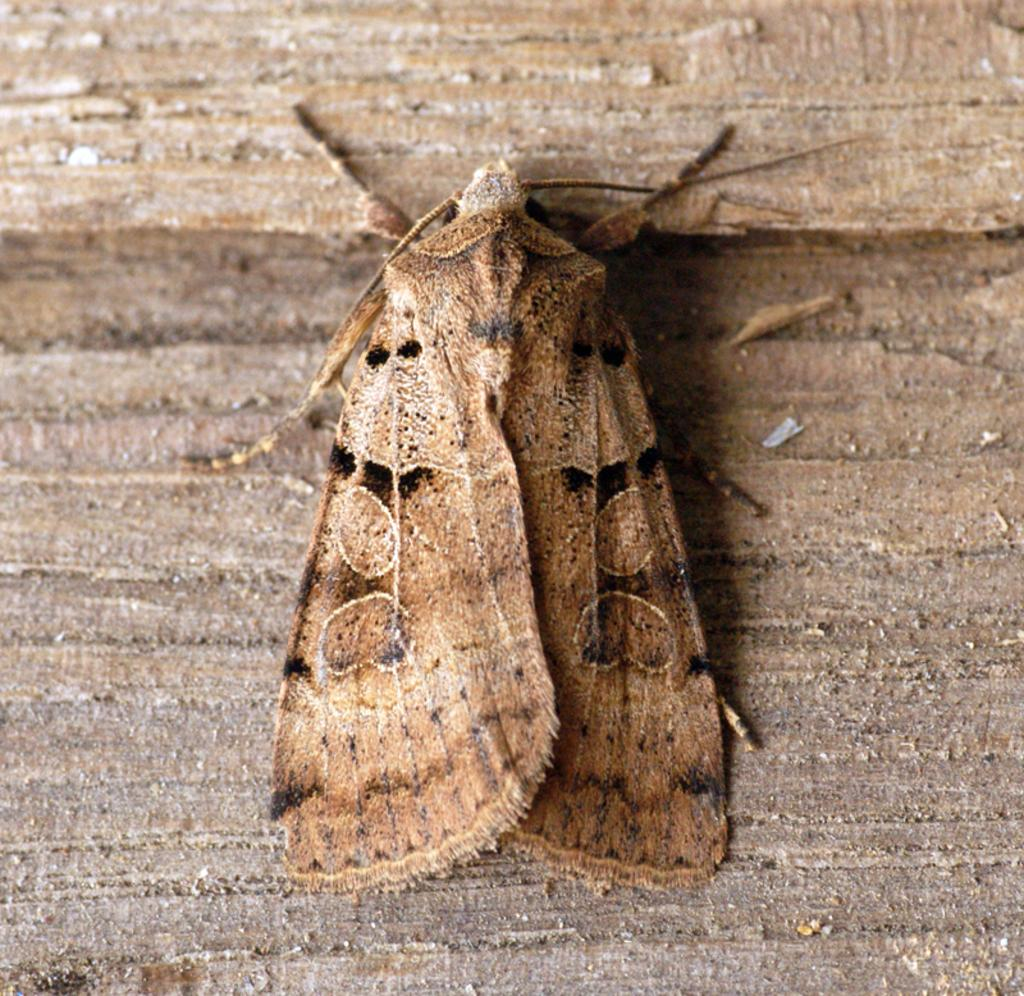What is the main subject in the center of the image? There is a fly in the center of the image. What type of surface is the fly on? The fly is on a wooden surface. What type of sun can be seen in the image? There is no sun present in the image. What shape does the fly form in the image? The fly does not form a specific shape in the image. 